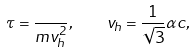<formula> <loc_0><loc_0><loc_500><loc_500>\tau = \frac { } { m v ^ { 2 } _ { h } } , \quad v _ { h } = \frac { 1 } { \sqrt { 3 } } \alpha c ,</formula> 